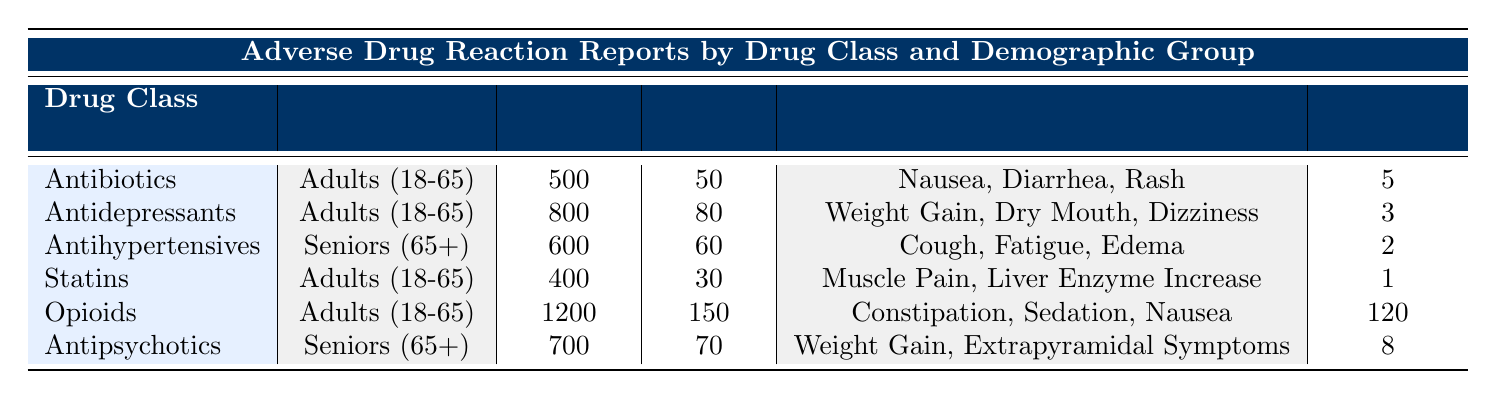What drug class has the highest number of total reports? The total reports for each drug class are as follows: Antibiotics (500), Antidepressants (800), Antihypertensives (600), Statins (400), Opioids (1200), and Antipsychotics (700). Among these, Opioids have the highest total reports at 1200.
Answer: Opioids How many fatalities are reported for Antihypertensives? The row for Antihypertensives shows that there are 2 fatalities reported.
Answer: 2 What is the average number of serious adverse events reported for drugs among Adults (18-65)? The serious adverse events for drugs in the Adults (18-65) are: Antibiotics (50), Antidepressants (80), Statins (30), and Opioids (150). First, sum them: 50 + 80 + 30 + 150 = 310. There are 4 drug classes, so the average is 310 / 4 = 77.5.
Answer: 77.5 Are there any drugs in this table that report more than 100 fatalities? The Opioids class has 120 fatalities, while the other classes have fewer fatalities: Antidepressants (3), Antihypertensives (2), Statins (1), and Antipsychotics (8). Therefore, Yes, Opioids is the only drug class that reports more than 100 fatalities.
Answer: Yes Which demographic group has reported the highest number of serious adverse events for a single drug class? The serious adverse events are: Adults (18-65) - Opioids (150), Antidepressants (80), Antibiotics (50), and Seniors (65+) - Antipsychotics (70) and Antihypertensives (60). The highest is for Opioids among Adults (18-65) at 150 serious events.
Answer: Adults (18-65) with Opioids What percentage of total reports for Statins resulted in serious adverse events? The total reports for Statins are 400, and the serious adverse events are 30. To find the percentage, divide 30 by 400 and multiply by 100: (30 / 400) * 100 = 7.5%.
Answer: 7.5% Is the total number of reports higher for Seniors (65+) compared to Adults (18-65)? For Seniors (65+), the total reports are: Antihypertensives (600) and Antipsychotics (700), totaling 1300. For Adults (18-65), the total reports are: Antibiotics (500), Antidepressants (800), Statins (400), and Opioids (1200), totaling 2900. Since 2900 > 1300, the total reports for Adults (18-65) are higher.
Answer: No What is the most common reaction reported for Antipsychotics? The common reactions listed for Antipsychotics include Weight Gain and Extrapyramidal Symptoms. The most repeated reaction among the reported adverse reactions for this class would be considered Weight Gain.
Answer: Weight Gain 